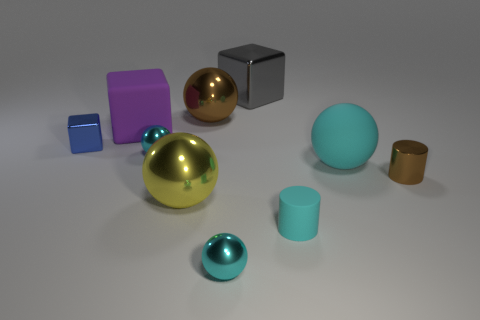Subtract all cyan balls. How many were subtracted if there are1cyan balls left? 2 Subtract all big purple cubes. How many cubes are left? 2 Subtract all yellow spheres. How many spheres are left? 4 Add 1 brown shiny cylinders. How many brown shiny cylinders exist? 2 Subtract 0 yellow cylinders. How many objects are left? 10 Subtract all cylinders. How many objects are left? 8 Subtract 1 blocks. How many blocks are left? 2 Subtract all brown cylinders. Subtract all gray spheres. How many cylinders are left? 1 Subtract all purple cylinders. How many blue cubes are left? 1 Subtract all tiny green objects. Subtract all large gray cubes. How many objects are left? 9 